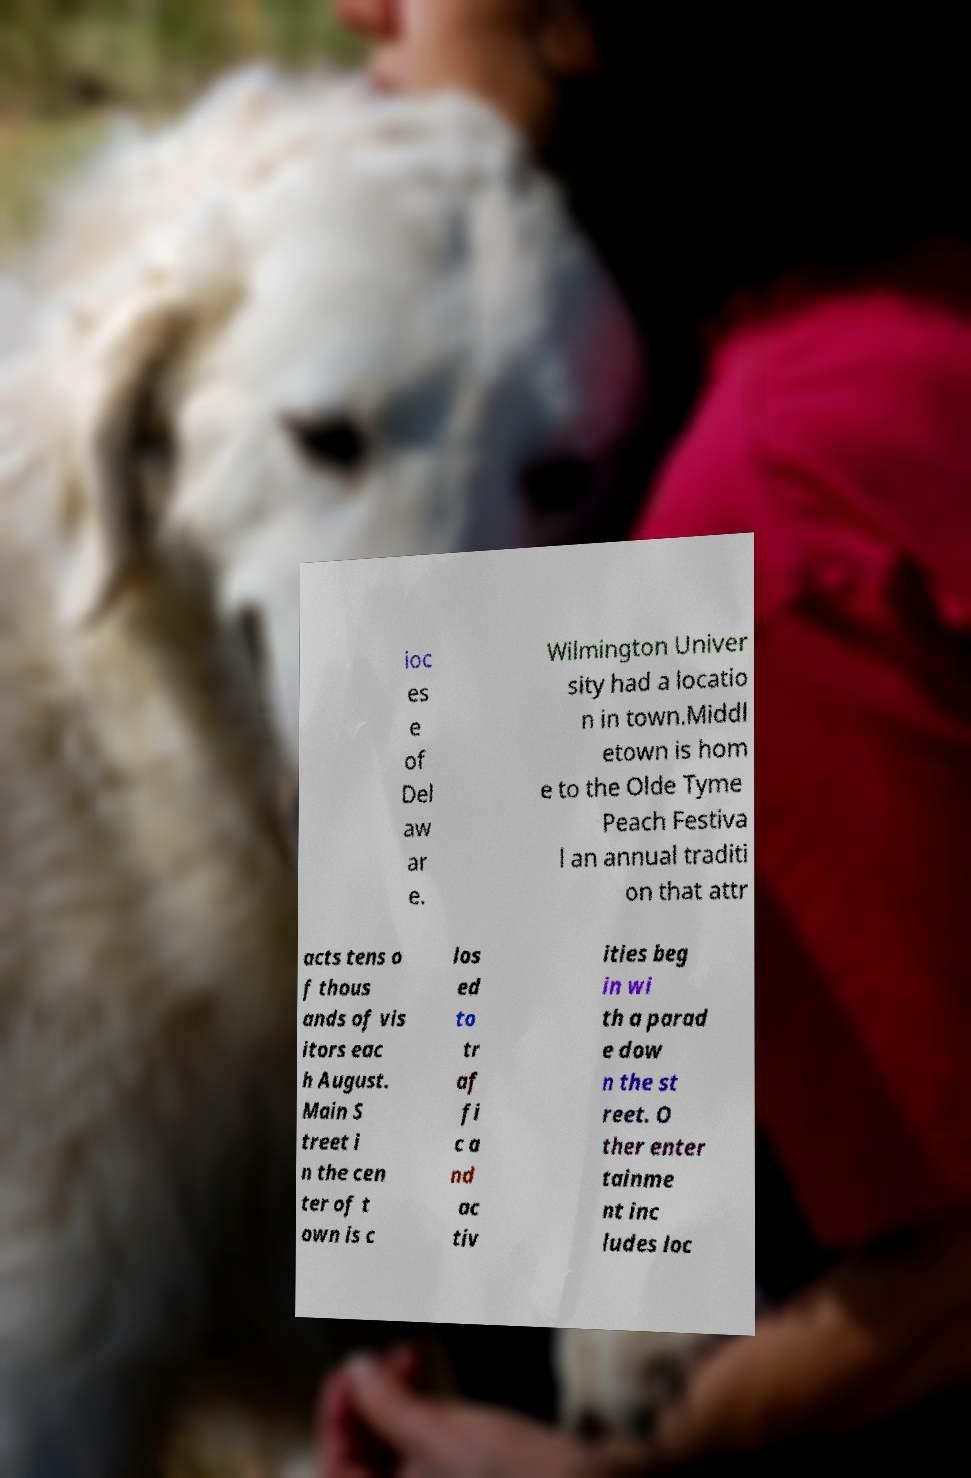Please identify and transcribe the text found in this image. ioc es e of Del aw ar e. Wilmington Univer sity had a locatio n in town.Middl etown is hom e to the Olde Tyme Peach Festiva l an annual traditi on that attr acts tens o f thous ands of vis itors eac h August. Main S treet i n the cen ter of t own is c los ed to tr af fi c a nd ac tiv ities beg in wi th a parad e dow n the st reet. O ther enter tainme nt inc ludes loc 